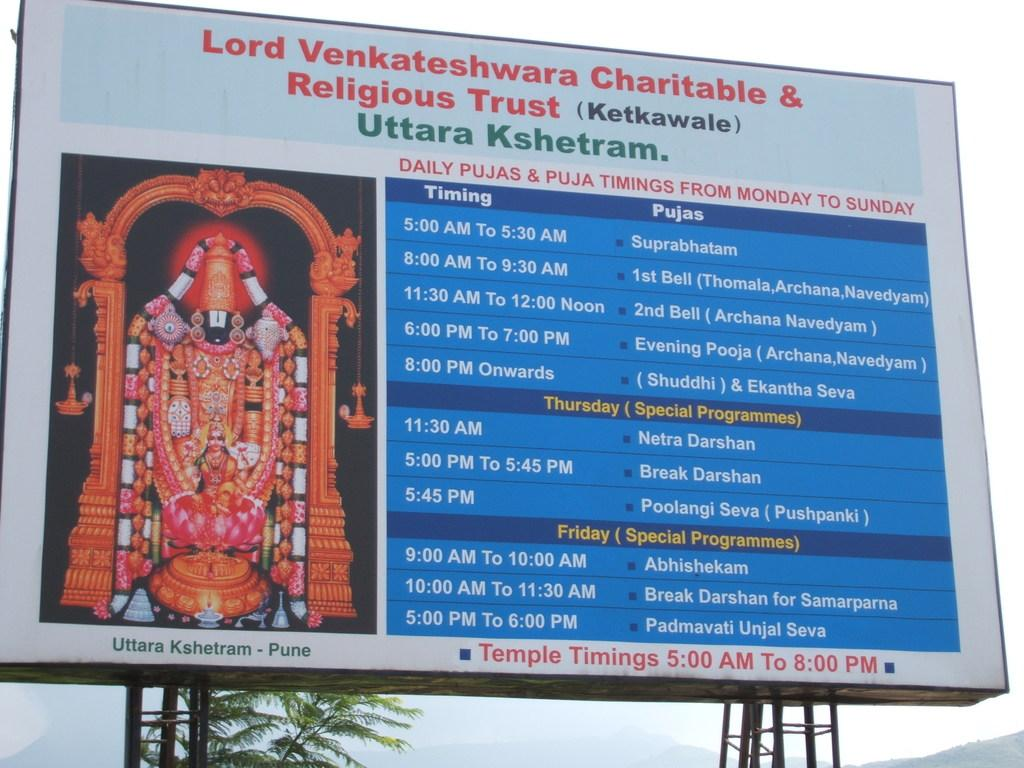<image>
Render a clear and concise summary of the photo. A large sign that says Lord Venkateshwara Charitable & Religious Trust with a picture of a deity 